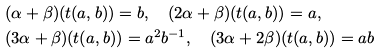Convert formula to latex. <formula><loc_0><loc_0><loc_500><loc_500>& ( \alpha + \beta ) ( t ( a , b ) ) = b , \quad ( 2 \alpha + \beta ) ( t ( a , b ) ) = a , \\ & ( 3 \alpha + \beta ) ( t ( a , b ) ) = a ^ { 2 } b ^ { - 1 } , \quad ( 3 \alpha + 2 \beta ) ( t ( a , b ) ) = a b</formula> 